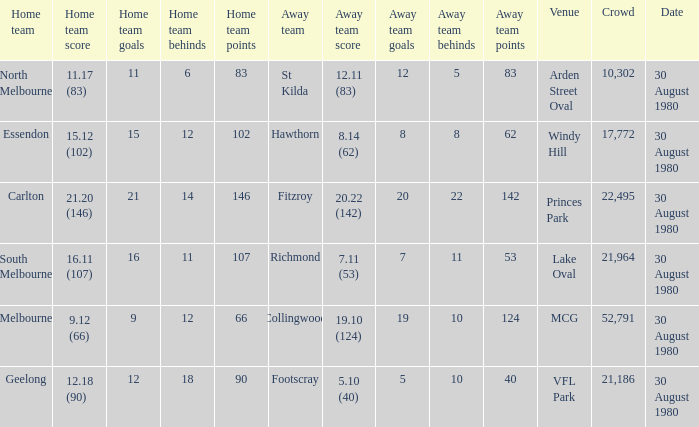What was the crowd when the away team is footscray? 21186.0. 